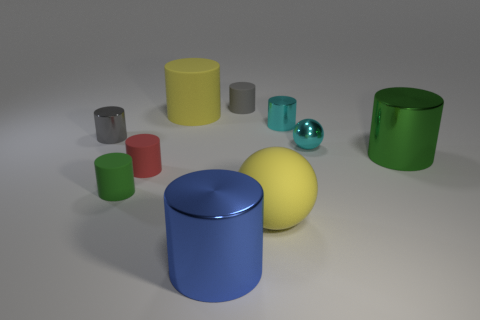Are there fewer tiny cylinders that are in front of the blue metallic object than gray cylinders on the right side of the tiny gray metal thing?
Provide a succinct answer. Yes. What is the shape of the thing that is the same color as the big matte cylinder?
Provide a short and direct response. Sphere. How many metal balls have the same size as the red rubber object?
Ensure brevity in your answer.  1. Is the gray object that is to the left of the large blue metal object made of the same material as the large blue object?
Make the answer very short. Yes. Are any tiny gray shiny cylinders visible?
Your answer should be compact. Yes. There is a yellow object that is made of the same material as the big yellow ball; what size is it?
Your answer should be compact. Large. Are there any tiny shiny cylinders of the same color as the large matte ball?
Provide a succinct answer. No. There is a small cylinder in front of the red matte cylinder; does it have the same color as the big object that is right of the tiny cyan shiny cylinder?
Offer a very short reply. Yes. There is a sphere that is the same color as the large matte cylinder; what is its size?
Provide a succinct answer. Large. Are there any tiny gray things made of the same material as the small cyan ball?
Offer a very short reply. Yes. 